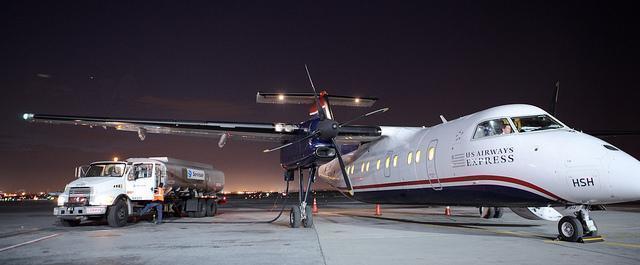What color is the underbelly of this private jet?
Answer the question by selecting the correct answer among the 4 following choices and explain your choice with a short sentence. The answer should be formatted with the following format: `Answer: choice
Rationale: rationale.`
Options: Green, blue, orange, black. Answer: black.
Rationale: The belly of the jet is black. 